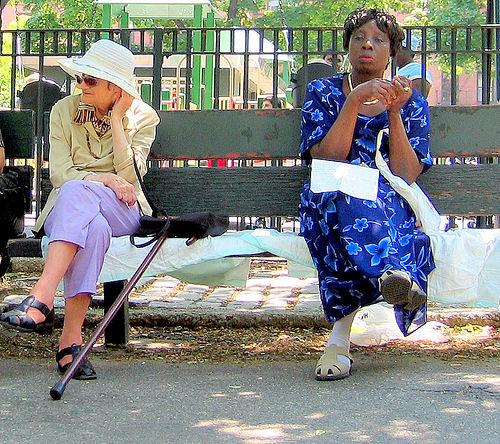Are the people in this image of the same nationality?
Answer briefly. No. What object is next to purse of the lady with the hat?
Write a very short answer. Cane. What are the women sitting on?
Quick response, please. Bench. 